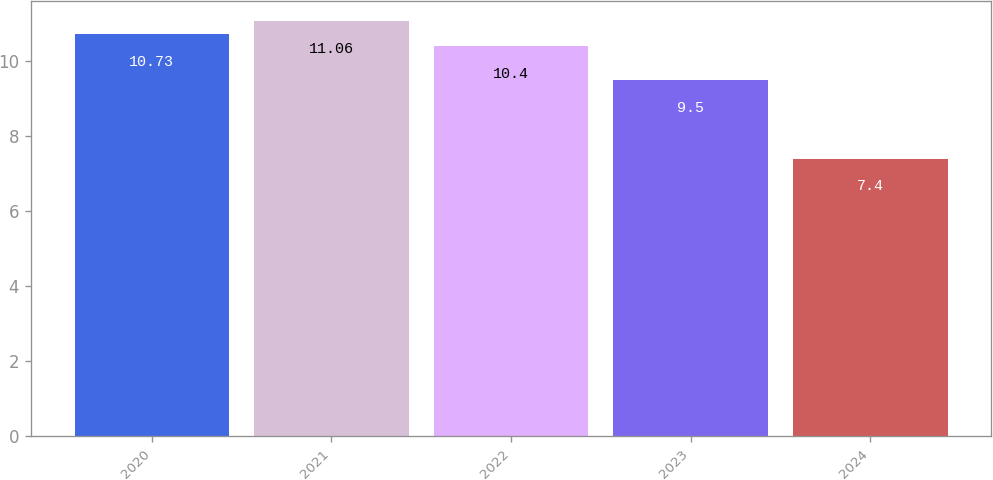Convert chart. <chart><loc_0><loc_0><loc_500><loc_500><bar_chart><fcel>2020<fcel>2021<fcel>2022<fcel>2023<fcel>2024<nl><fcel>10.73<fcel>11.06<fcel>10.4<fcel>9.5<fcel>7.4<nl></chart> 